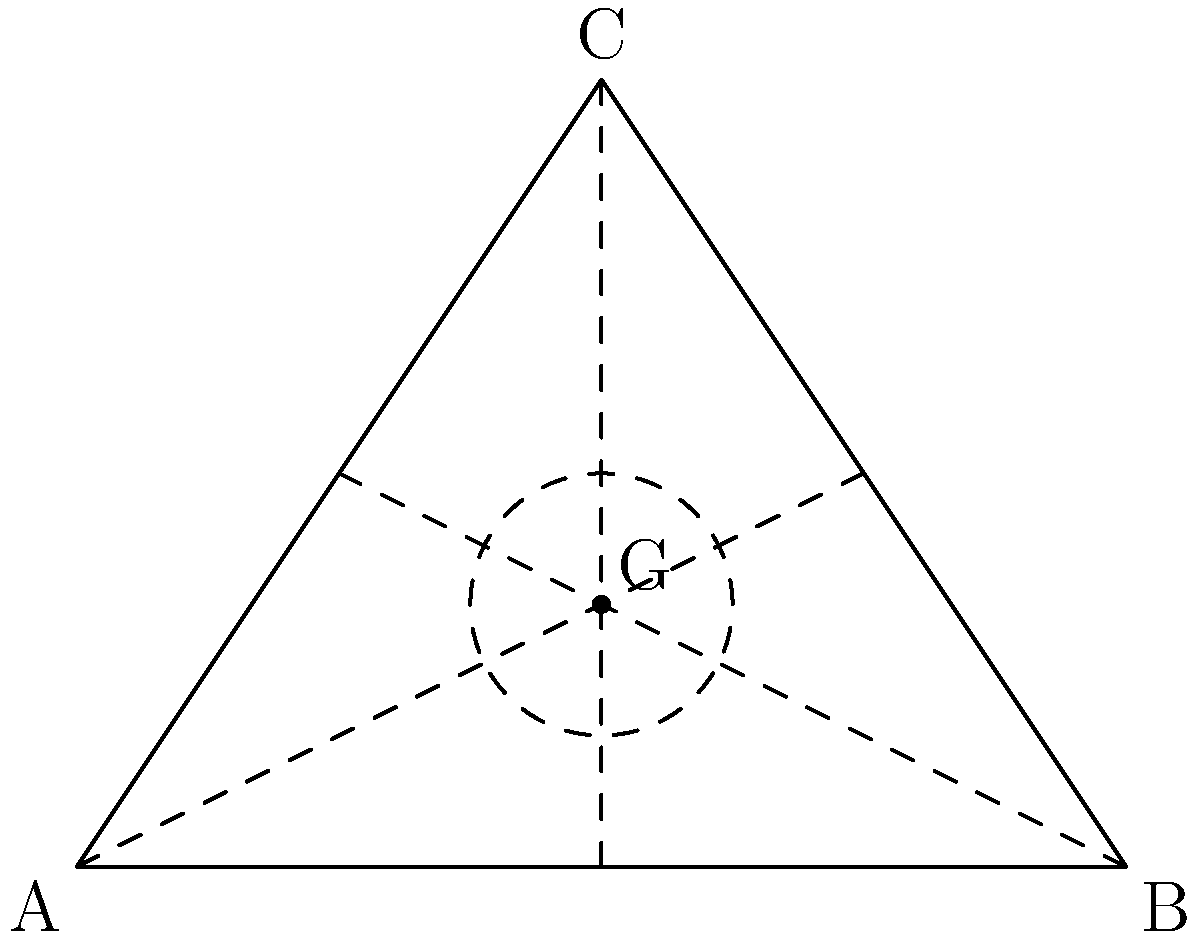In designing a stealth aircraft, you've determined that a triangular shape offers the best radar cross-section reduction. Given an equilateral triangle ABC representing the aircraft's base, which point within the triangle would be ideal for placing a critical component to minimize its visibility to radar systems? To determine the ideal point for placing a critical component within an equilateral triangle to minimize radar visibility, we need to consider the concept of the centroid. Here's why:

1. The centroid (G) of a triangle is the point where all three medians intersect.

2. Medians are lines that connect a vertex to the midpoint of the opposite side.

3. The centroid divides each median in a 2:1 ratio, meaning it's located 2/3 of the way from any vertex to the midpoint of the opposite side.

4. This point has several properties that make it ideal for stealth purposes:

   a) It's equidistant from all sides of the triangle, minimizing the chance of detection from any single direction.
   
   b) It's the center of mass of the triangle, providing balance and stability for the component.
   
   c) It's the deepest point within the triangle, offering maximum shielding from external radar.

5. The coordinates of the centroid in an equilateral triangle can be calculated as:

   $$G_x = \frac{x_A + x_B + x_C}{3}, G_y = \frac{y_A + y_B + y_C}{3}$$

   Where $(x_A, y_A)$, $(x_B, y_B)$, and $(x_C, y_C)$ are the coordinates of the triangle's vertices.

6. In the context of stealth technology, placing a critical component at the centroid would provide the most uniform radar cross-section from all angles, making it harder for radar systems to detect and identify the aircraft.

Therefore, the ideal point for placing a critical component to minimize radar visibility would be the centroid of the equilateral triangle.
Answer: The centroid (G) 